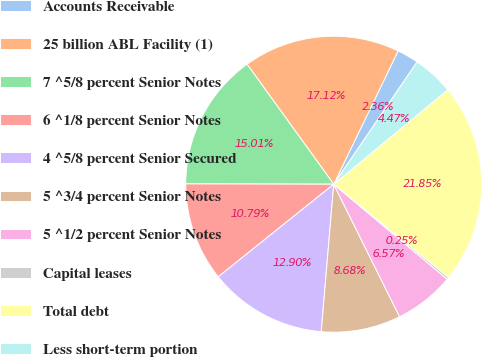<chart> <loc_0><loc_0><loc_500><loc_500><pie_chart><fcel>Accounts Receivable<fcel>25 billion ABL Facility (1)<fcel>7 ^5/8 percent Senior Notes<fcel>6 ^1/8 percent Senior Notes<fcel>4 ^5/8 percent Senior Secured<fcel>5 ^3/4 percent Senior Notes<fcel>5 ^1/2 percent Senior Notes<fcel>Capital leases<fcel>Total debt<fcel>Less short-term portion<nl><fcel>2.36%<fcel>17.12%<fcel>15.01%<fcel>10.79%<fcel>12.9%<fcel>8.68%<fcel>6.57%<fcel>0.25%<fcel>21.85%<fcel>4.47%<nl></chart> 